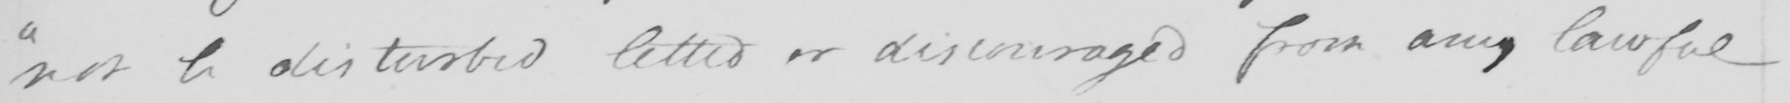Can you read and transcribe this handwriting? " not be disturbed letted or discouraged from any lawful 